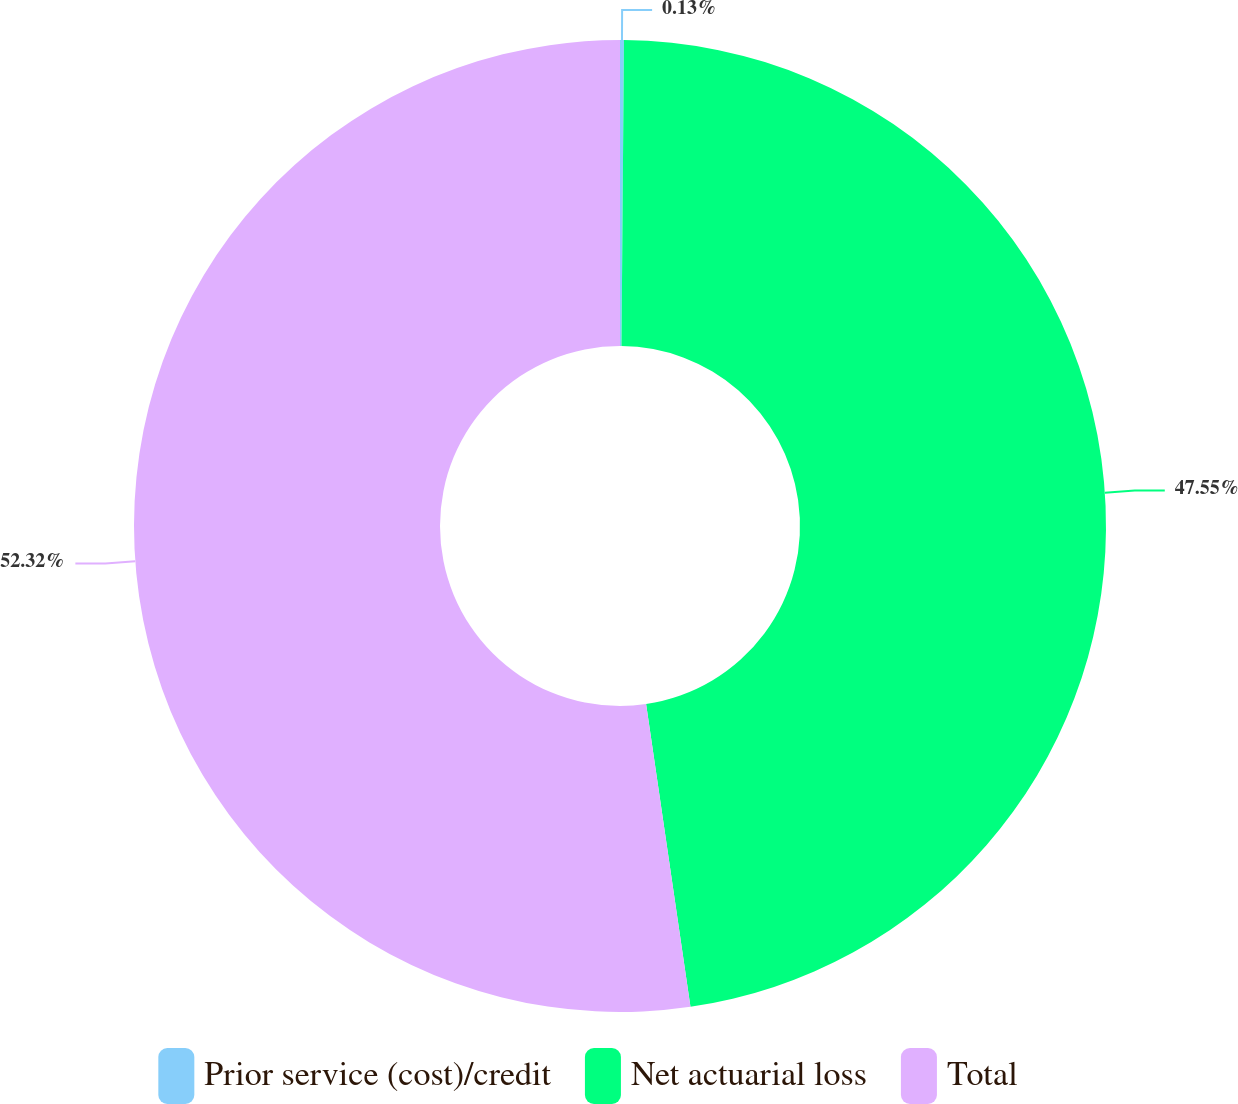Convert chart. <chart><loc_0><loc_0><loc_500><loc_500><pie_chart><fcel>Prior service (cost)/credit<fcel>Net actuarial loss<fcel>Total<nl><fcel>0.13%<fcel>47.55%<fcel>52.31%<nl></chart> 